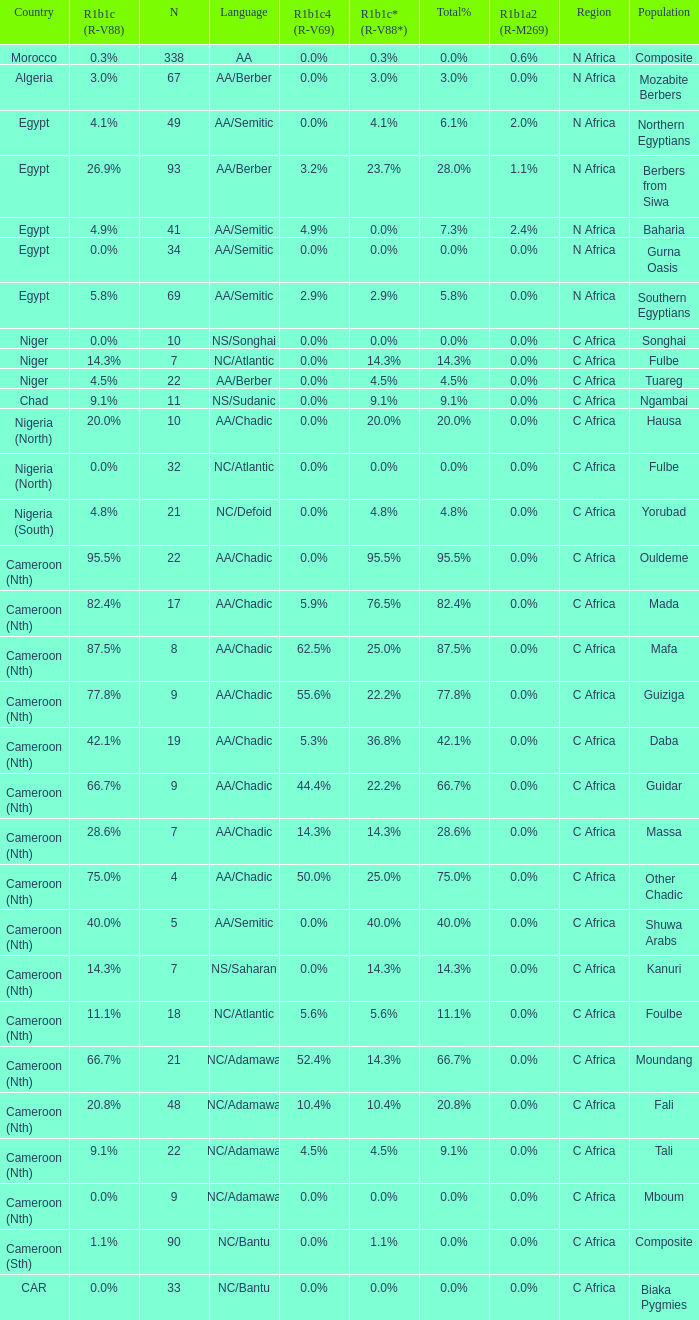What languages are spoken in Niger with r1b1c (r-v88) of 0.0%? NS/Songhai. 